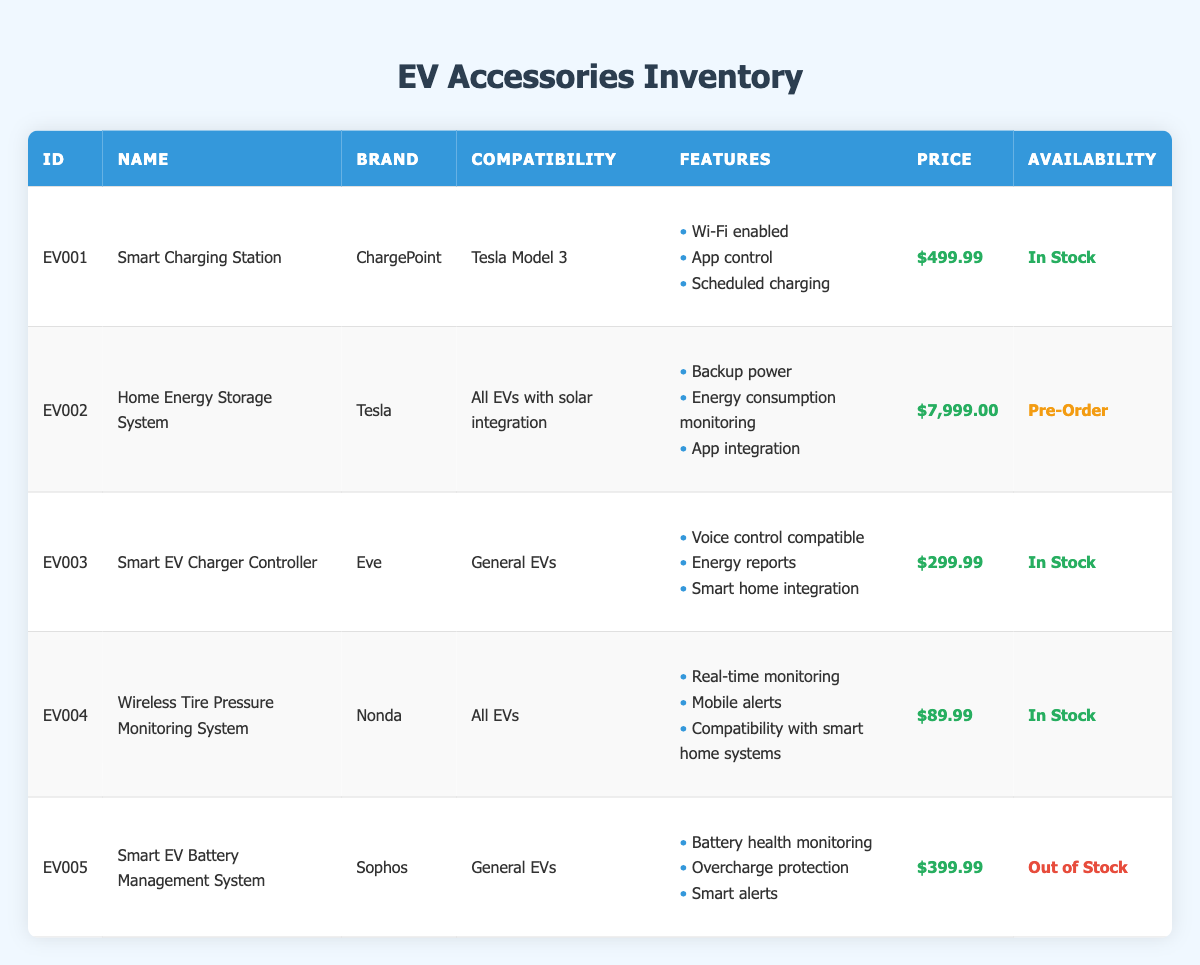What is the price of the Smart Charging Station? According to the table, the price of the Smart Charging Station (accessory_id EV001) is listed adjacent to its name in the price column. The price shows as $499.99.
Answer: $499.99 How many accessories are currently in stock? To find the number of accessories available, I can count the rows where the availability status shows "In Stock". From the table, the accessories with "In Stock" status are the Smart Charging Station, Smart EV Charger Controller, and Wireless Tire Pressure Monitoring System, which gives us a total of 3.
Answer: 3 Which accessory has the highest price? In the price column, I need to look through all the accessories listed. The Home Energy Storage System is priced at $7,999.00, which is higher than all other prices in the table.
Answer: Home Energy Storage System Is the Wireless Tire Pressure Monitoring System compatible with all electric vehicles? The table indicates that the compatibility for the Wireless Tire Pressure Monitoring System (accessory_id EV004) is listed as "All EVs". Therefore, the statement is true.
Answer: Yes What are the features of the Smart EV Charger Controller? The features of the Smart EV Charger Controller (accessory_id EV003) are listed in the features column. They include Voice control compatible, Energy reports, and Smart home integration.
Answer: Voice control compatible, Energy reports, Smart home integration What is the total price of all accessories that are currently in stock? To find the total price, I need to add the prices of the accessories that have "In Stock" status. The prices are $499.99 (Smart Charging Station) + $299.99 (Smart EV Charger Controller) + $89.99 (Wireless Tire Pressure Monitoring System), which totals $889.97.
Answer: $889.97 Are all accessories from the brand Tesla? Examining the brand column, I see that there are accessories from multiple brands: ChargePoint, Tesla, Eve, Nonda, and Sophos. Since not all accessories are from Tesla, the statement is false.
Answer: No What is the price difference between the Home Energy Storage System and the Smart EV Battery Management System? First, I locate the prices in the table: the Home Energy Storage System is $7999.00 and the Smart EV Battery Management System is $399.99. The difference is calculated as $7999.00 - $399.99, which equals $7600.01.
Answer: $7600.01 How many features does the Smart Charging Station have? The features of the Smart Charging Station (accessory_id EV001) are itemized in a list, showing three features: Wi-Fi enabled, App control, and Scheduled charging. Therefore, it has a total of 3 features.
Answer: 3 